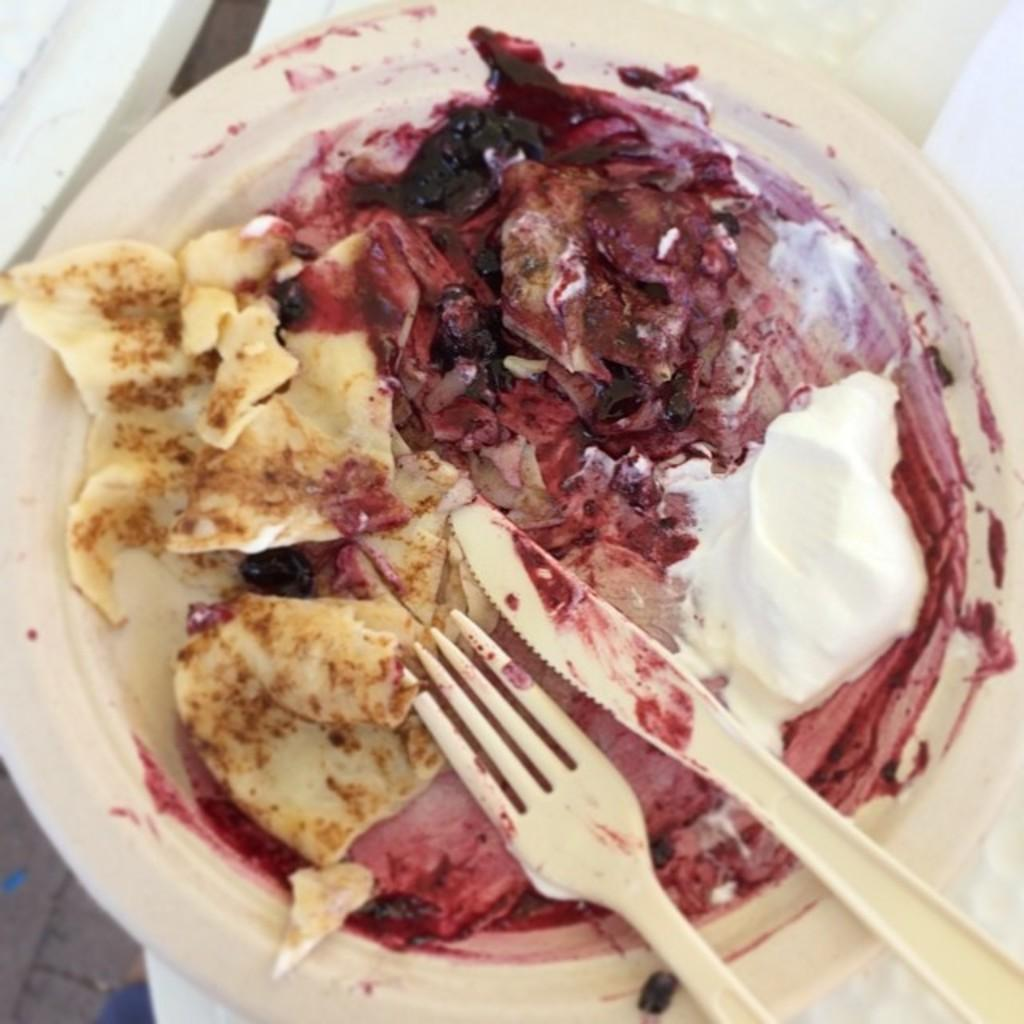What is on the plate that is visible in the image? There is a plate with food items in the image. What utensils are present in the image? There is a knife and a fork in the image. How many governors are present in the image? There are no governors present in the image; it features a plate with food items and utensils. 